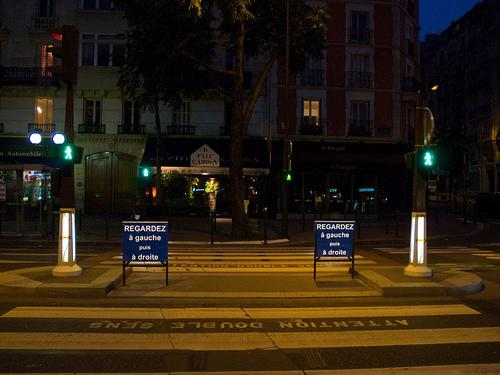What language is probably spoken in this locale?

Choices:
A) spanish
B) italian
C) french
D) portuguese french 